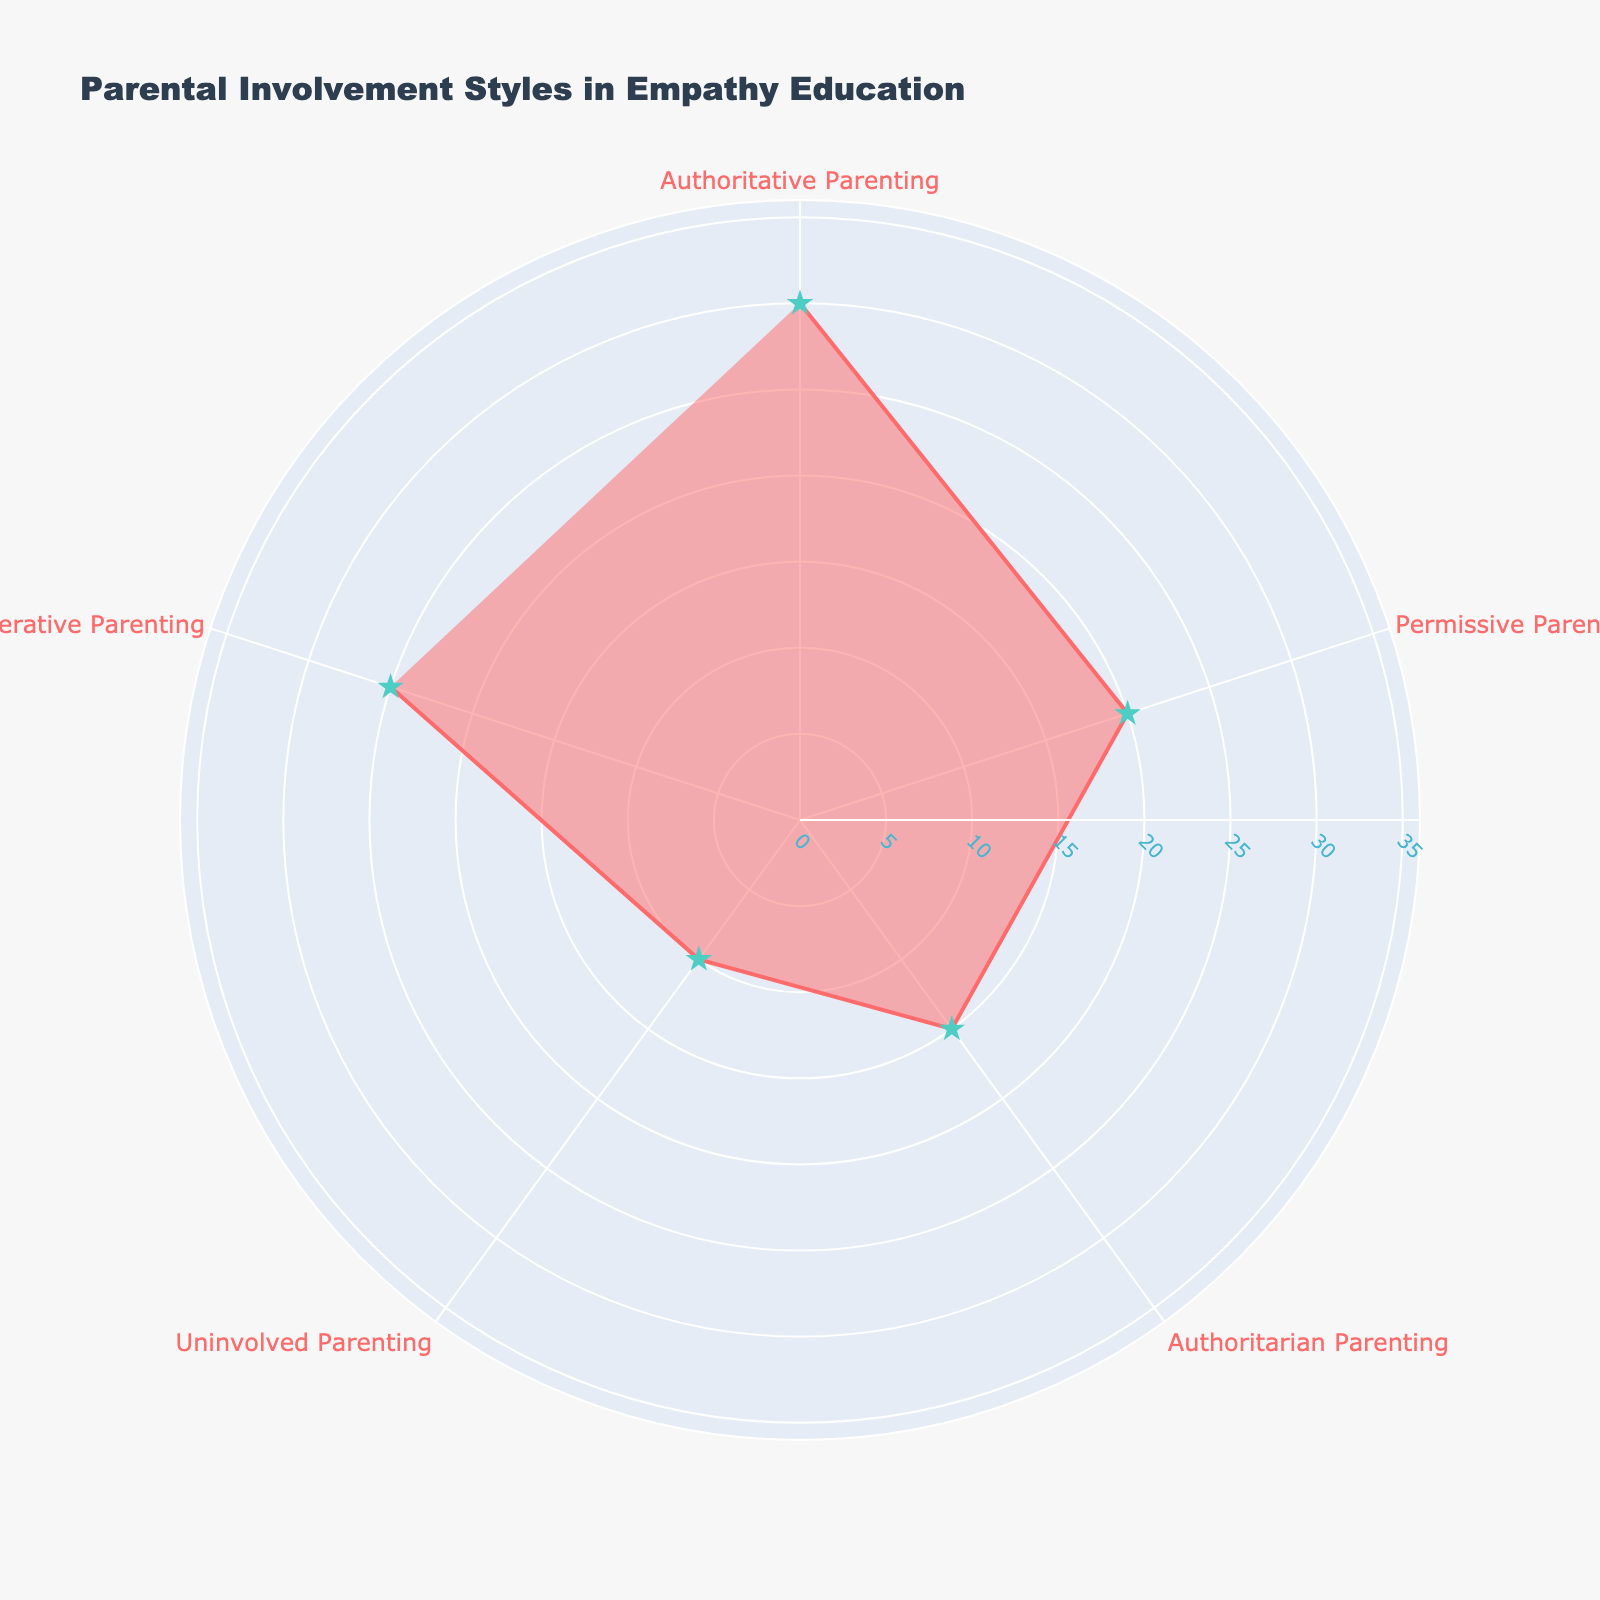What's the title of the figure? The title is usually displayed at the top of the chart. Here, the title text is clearly stated and visible.
Answer: Parental Involvement Styles in Empathy Education What color is used to fill the polar chart? The fill color is visibly seen inside the plotted area and can be described by its appearance.
Answer: A shade of red (#FF6B6B) with transparency Which parenting style has the highest percentage? By inspecting the radial length of each category on the chart, the one that extends the farthest radius will have the highest percentage.
Answer: Authoritative Parenting What is the combined percentage of Authoritarian Parenting and Uninvolved Parenting styles? Look for the given percentages of both Authoritarian Parenting (15%) and Uninvolved Parenting (10%), and then sum them up: 15 + 10 = 25.
Answer: 25% How many different parental involvement styles are visualized in the figure? Counting the different labeled segments will give you the number of styles. Here, each category has a label.
Answer: 5 How does the percentage of Permissive Parenting compare to Cooperative Parenting? Compare the lengths or percentages directly from the figure: Permissive Parenting is 20% and Cooperative Parenting is 25%.
Answer: Cooperative Parenting is higher by 5% What's the average percentage value of all the parenting styles? To find the average, sum all the percentages and divide by the number of categories: (30 + 20 + 15 + 10 + 25) / 5 = 20%.
Answer: 20% Which parental involvement style has the smallest percentage and how much is it? Visually find the shortest radial line on the chart, indicating the smallest category, then read the percentage.
Answer: Uninvolved Parenting, 10% If the percentages are sorted in descending order, what position does Authoritarian Parenting hold? Sorting the values from highest to lowest: 30, 25, 20, 15, 10. Authoritarian Parenting (15%) is 4th.
Answer: 4th In what direction are the categories arranged around the chart? Observing the angular labels, one can see the direction in which they increase.
Answer: Clockwise 